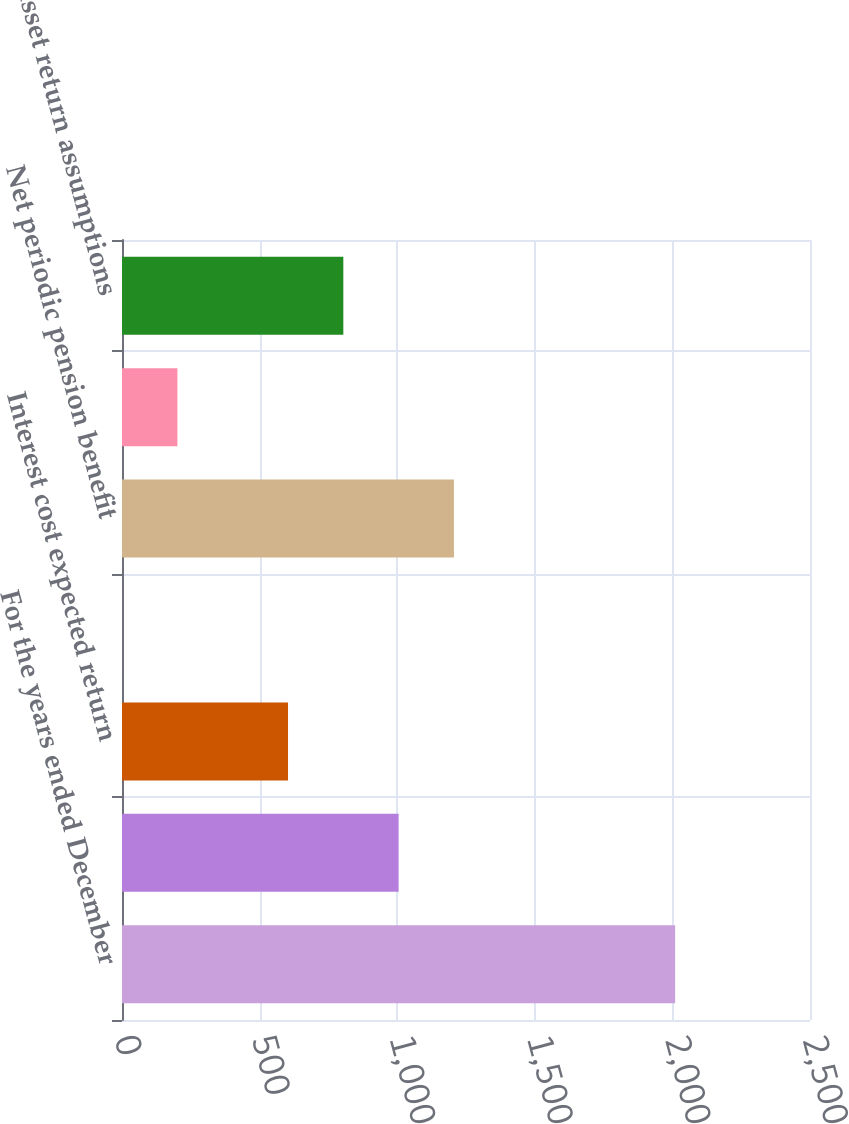Convert chart. <chart><loc_0><loc_0><loc_500><loc_500><bar_chart><fcel>For the years ended December<fcel>Service cost and amortization<fcel>Interest cost expected return<fcel>Administrative expenses<fcel>Net periodic pension benefit<fcel>Average discount rate<fcel>Asset return assumptions<nl><fcel>2010<fcel>1005.2<fcel>603.28<fcel>0.4<fcel>1206.16<fcel>201.36<fcel>804.24<nl></chart> 